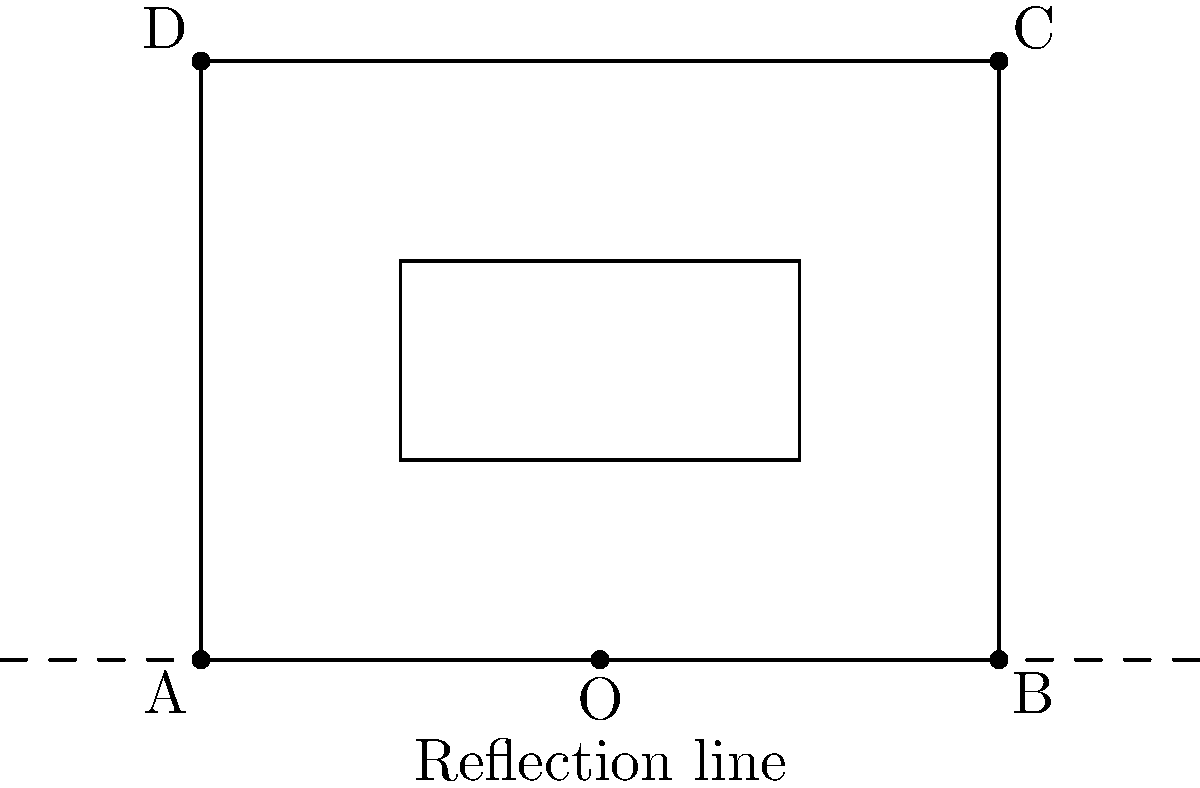Henry's garden layout is represented by the solid rectangle ABCD with a flower bed EFGH inside. If Henry wants to reflect this layout across the dashed line to create a mirror image for his new garden expansion, what will be the coordinates of point C' (the reflection of point C) in the new layout? To find the coordinates of C' after reflection:

1. Identify the original coordinates of C: (4,3)
2. The reflection line is the x-axis (y=0)
3. For reflection across the x-axis:
   - The x-coordinate remains the same
   - The y-coordinate changes sign
4. So, the coordinates of C' will be (4, -3)

Alternatively, we can think of this as:
- The distance of C from the reflection line is 3 units above
- After reflection, C' will be 3 units below the line
- The x-coordinate doesn't change

Therefore, C' will be at (4, -3).
Answer: (4, -3) 